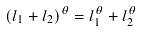<formula> <loc_0><loc_0><loc_500><loc_500>( l _ { 1 } + l _ { 2 } ) ^ { \theta } = l _ { 1 } ^ { \theta } + l _ { 2 } ^ { \theta }</formula> 